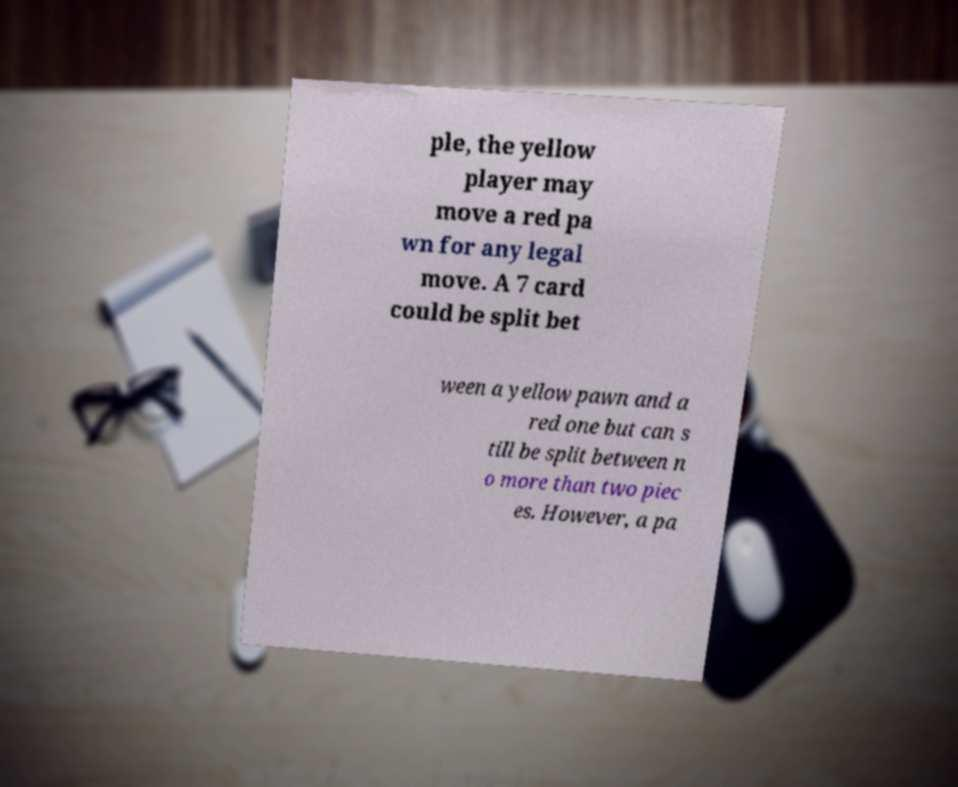Can you accurately transcribe the text from the provided image for me? ple, the yellow player may move a red pa wn for any legal move. A 7 card could be split bet ween a yellow pawn and a red one but can s till be split between n o more than two piec es. However, a pa 